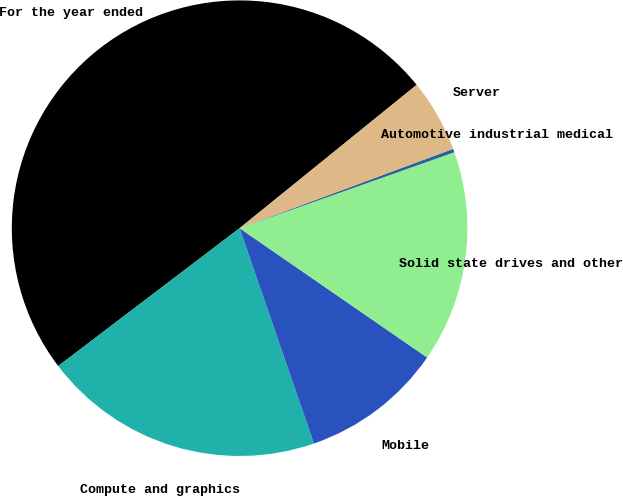Convert chart. <chart><loc_0><loc_0><loc_500><loc_500><pie_chart><fcel>For the year ended<fcel>Compute and graphics<fcel>Mobile<fcel>Solid state drives and other<fcel>Automotive industrial medical<fcel>Server<nl><fcel>49.51%<fcel>19.95%<fcel>10.1%<fcel>15.02%<fcel>0.25%<fcel>5.17%<nl></chart> 